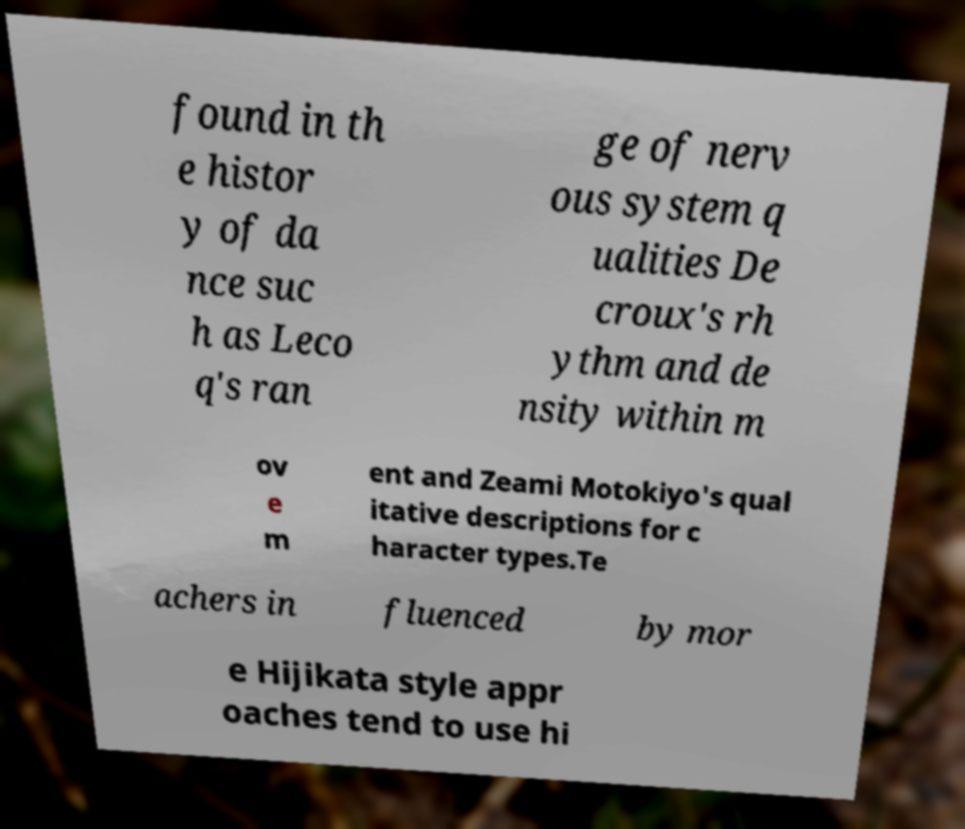For documentation purposes, I need the text within this image transcribed. Could you provide that? found in th e histor y of da nce suc h as Leco q's ran ge of nerv ous system q ualities De croux's rh ythm and de nsity within m ov e m ent and Zeami Motokiyo's qual itative descriptions for c haracter types.Te achers in fluenced by mor e Hijikata style appr oaches tend to use hi 